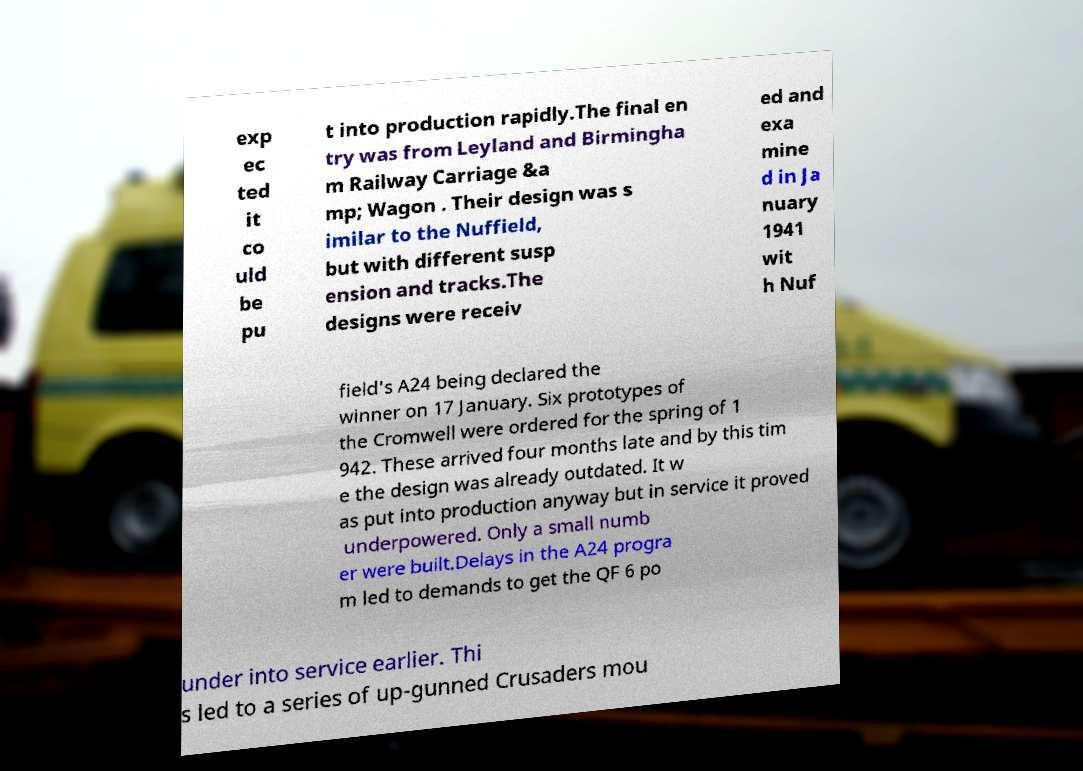Could you assist in decoding the text presented in this image and type it out clearly? exp ec ted it co uld be pu t into production rapidly.The final en try was from Leyland and Birmingha m Railway Carriage &a mp; Wagon . Their design was s imilar to the Nuffield, but with different susp ension and tracks.The designs were receiv ed and exa mine d in Ja nuary 1941 wit h Nuf field's A24 being declared the winner on 17 January. Six prototypes of the Cromwell were ordered for the spring of 1 942. These arrived four months late and by this tim e the design was already outdated. It w as put into production anyway but in service it proved underpowered. Only a small numb er were built.Delays in the A24 progra m led to demands to get the QF 6 po under into service earlier. Thi s led to a series of up-gunned Crusaders mou 